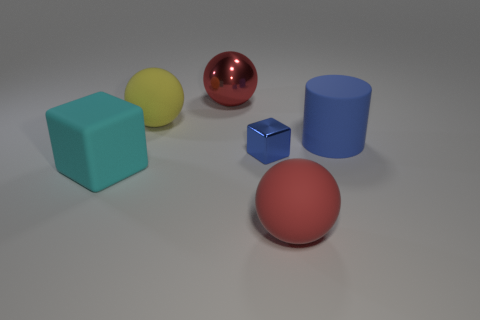How many tiny blue blocks are the same material as the small object? Upon reviewing the image, I determined that there are no tiny blue blocks made of the same material as any of the visible objects. Each object appears unique in its material. 